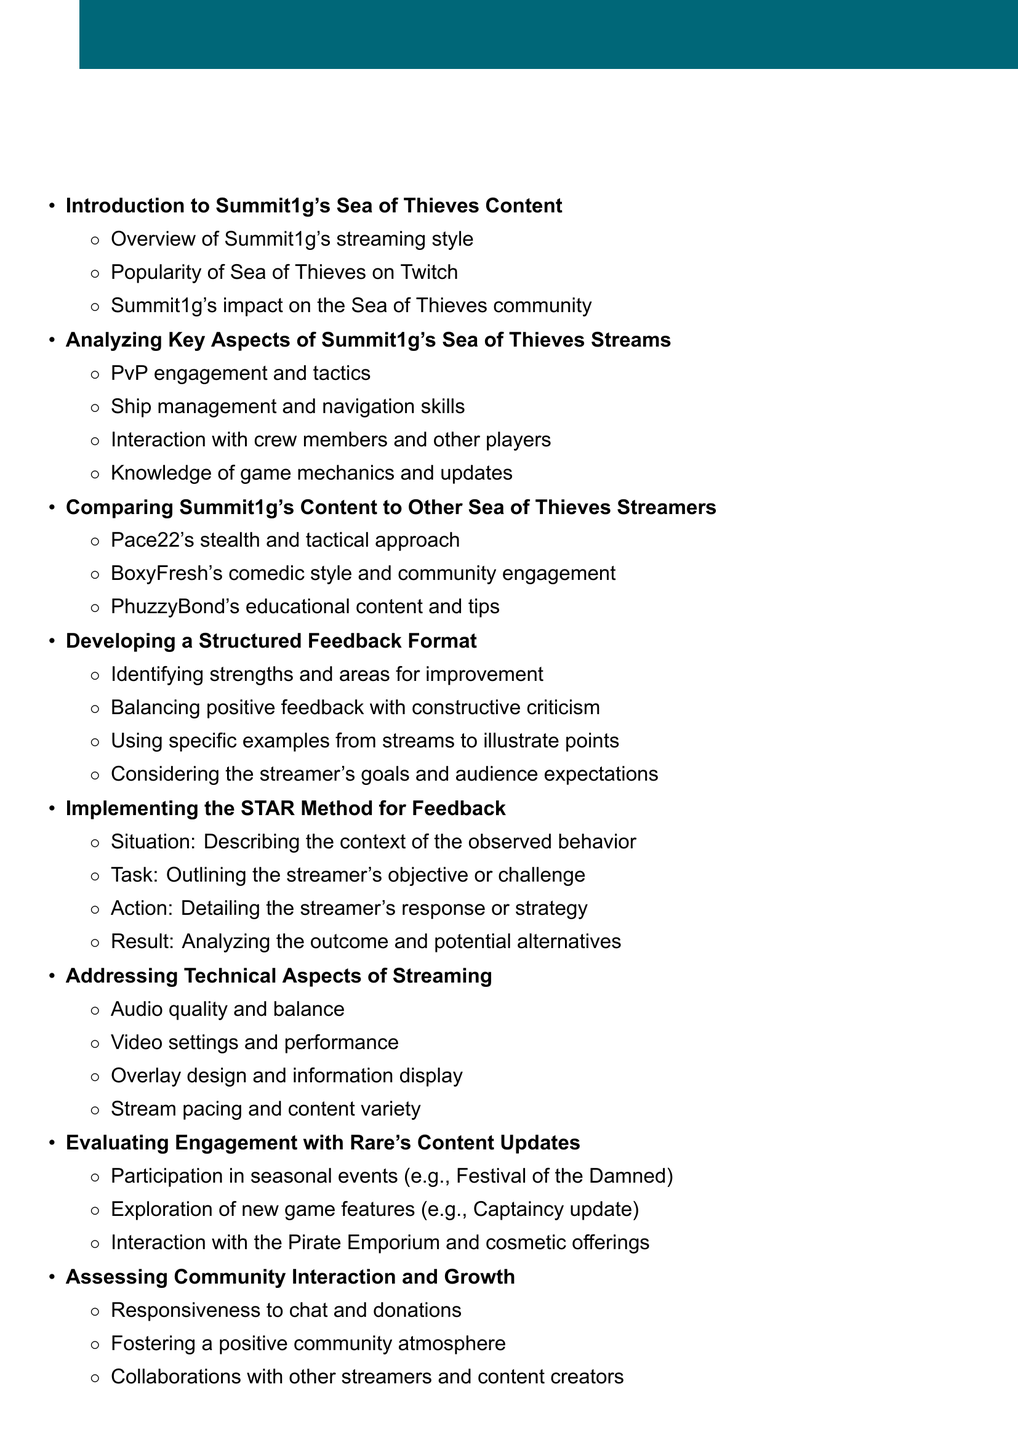What is the first item on the agenda? The first item on the agenda is titled "Introduction to Summit1g's Sea of Thieves Content."
Answer: Introduction to Summit1g's Sea of Thieves Content How many points are under the "Analyzing Key Aspects of Summit1g's Sea of Thieves Streams" section? There are four points listed under this section.
Answer: 4 What method is suggested for providing feedback? The document recommends the STAR Method for feedback.
Answer: STAR Method Which streamer is associated with a stealth and tactical approach? Pace22 is identified as using a stealth and tactical approach.
Answer: Pace22 What aspect of streaming does the document suggest should be addressed regarding audio? The document suggests addressing the audio quality and balance.
Answer: Audio quality and balance How many agenda items cover community interaction? There are two agenda items related to community interaction: "Assessing Community Interaction and Growth" and "Creating a Feedback Template."
Answer: 2 What is the purpose of the "Creating a Feedback Template" section? This section focuses on designing a user-friendly format for consistent feedback.
Answer: Designing a user-friendly format for consistent feedback What seasonal event is mentioned in the engagement with Rare's content updates? The Festival of the Damned is mentioned as a seasonal event.
Answer: Festival of the Damned What is the last agenda item titled? The last item on the agenda is titled "Conclusion: Implementing and Refining the Feedback Process."
Answer: Conclusion: Implementing and Refining the Feedback Process 